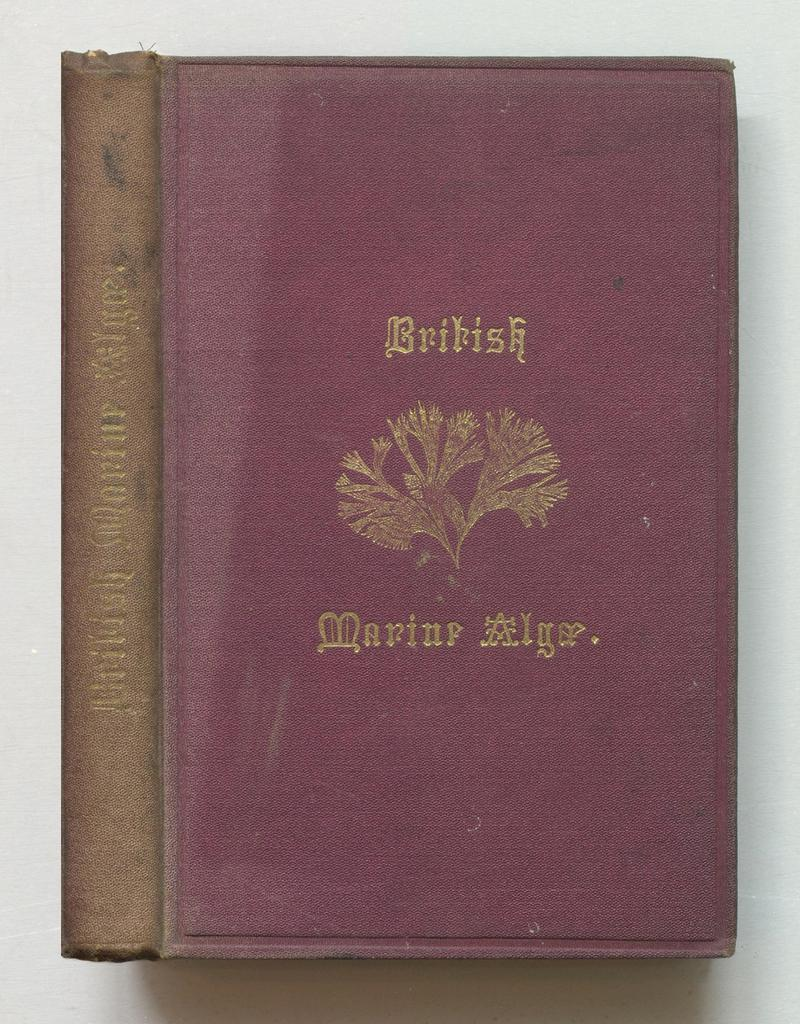Provide a one-sentence caption for the provided image. British Marine alga book with a tree logo on the front cover. 